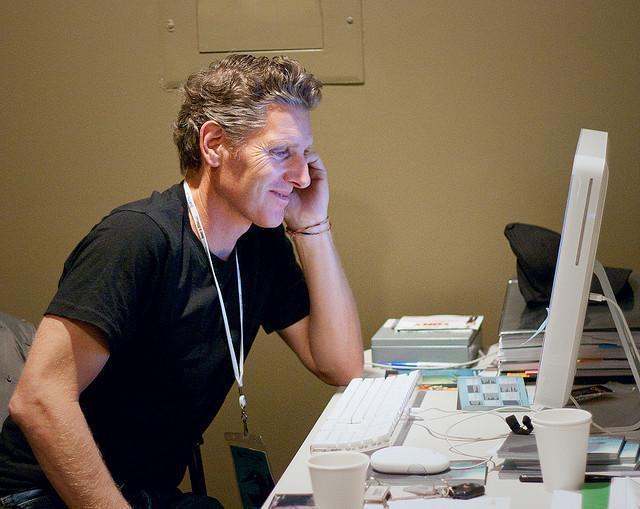What is closest to the computer screen?
From the following set of four choices, select the accurate answer to respond to the question.
Options: Cup, nose, printer, cat. Cup. 